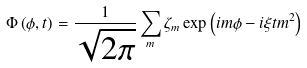Convert formula to latex. <formula><loc_0><loc_0><loc_500><loc_500>\Phi \left ( \phi , t \right ) = \frac { 1 } { \sqrt { 2 \pi } } \sum _ { m } \zeta _ { m } \exp \left ( i m \phi - i \xi t m ^ { 2 } \right )</formula> 